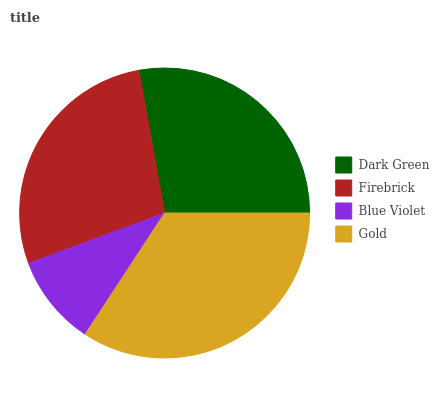Is Blue Violet the minimum?
Answer yes or no. Yes. Is Gold the maximum?
Answer yes or no. Yes. Is Firebrick the minimum?
Answer yes or no. No. Is Firebrick the maximum?
Answer yes or no. No. Is Dark Green greater than Firebrick?
Answer yes or no. Yes. Is Firebrick less than Dark Green?
Answer yes or no. Yes. Is Firebrick greater than Dark Green?
Answer yes or no. No. Is Dark Green less than Firebrick?
Answer yes or no. No. Is Dark Green the high median?
Answer yes or no. Yes. Is Firebrick the low median?
Answer yes or no. Yes. Is Gold the high median?
Answer yes or no. No. Is Blue Violet the low median?
Answer yes or no. No. 